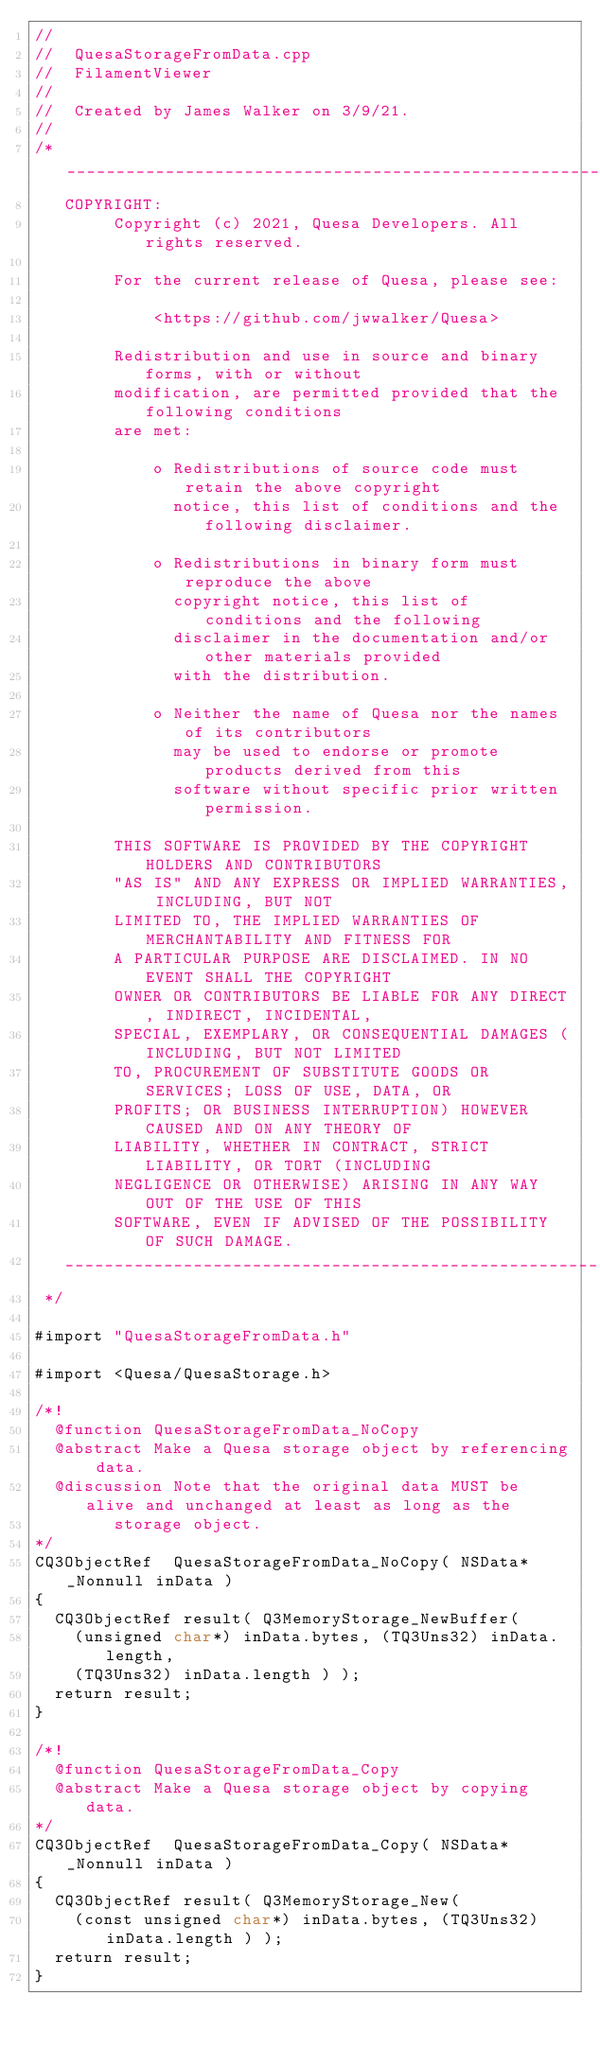Convert code to text. <code><loc_0><loc_0><loc_500><loc_500><_ObjectiveC_>//
//  QuesaStorageFromData.cpp
//  FilamentViewer
//
//  Created by James Walker on 3/9/21.
//
/* ___________________________________________________________________________
   COPYRIGHT:
        Copyright (c) 2021, Quesa Developers. All rights reserved.

        For the current release of Quesa, please see:

            <https://github.com/jwwalker/Quesa>
        
        Redistribution and use in source and binary forms, with or without
        modification, are permitted provided that the following conditions
        are met:
        
            o Redistributions of source code must retain the above copyright
              notice, this list of conditions and the following disclaimer.
        
            o Redistributions in binary form must reproduce the above
              copyright notice, this list of conditions and the following
              disclaimer in the documentation and/or other materials provided
              with the distribution.
        
            o Neither the name of Quesa nor the names of its contributors
              may be used to endorse or promote products derived from this
              software without specific prior written permission.
        
        THIS SOFTWARE IS PROVIDED BY THE COPYRIGHT HOLDERS AND CONTRIBUTORS
        "AS IS" AND ANY EXPRESS OR IMPLIED WARRANTIES, INCLUDING, BUT NOT
        LIMITED TO, THE IMPLIED WARRANTIES OF MERCHANTABILITY AND FITNESS FOR
        A PARTICULAR PURPOSE ARE DISCLAIMED. IN NO EVENT SHALL THE COPYRIGHT
        OWNER OR CONTRIBUTORS BE LIABLE FOR ANY DIRECT, INDIRECT, INCIDENTAL,
        SPECIAL, EXEMPLARY, OR CONSEQUENTIAL DAMAGES (INCLUDING, BUT NOT LIMITED
        TO, PROCUREMENT OF SUBSTITUTE GOODS OR SERVICES; LOSS OF USE, DATA, OR
        PROFITS; OR BUSINESS INTERRUPTION) HOWEVER CAUSED AND ON ANY THEORY OF
        LIABILITY, WHETHER IN CONTRACT, STRICT LIABILITY, OR TORT (INCLUDING
        NEGLIGENCE OR OTHERWISE) ARISING IN ANY WAY OUT OF THE USE OF THIS
        SOFTWARE, EVEN IF ADVISED OF THE POSSIBILITY OF SUCH DAMAGE.
   ___________________________________________________________________________
 */

#import "QuesaStorageFromData.h"

#import <Quesa/QuesaStorage.h>

/*!
	@function	QuesaStorageFromData_NoCopy
	@abstract	Make a Quesa storage object by referencing data.
	@discussion	Note that the original data MUST be alive and unchanged at least as long as the
				storage object.
*/
CQ3ObjectRef	QuesaStorageFromData_NoCopy( NSData* _Nonnull inData )
{
	CQ3ObjectRef result( Q3MemoryStorage_NewBuffer(
		(unsigned char*) inData.bytes, (TQ3Uns32) inData.length,
		(TQ3Uns32) inData.length ) );
	return result;
}

/*!
	@function	QuesaStorageFromData_Copy
	@abstract	Make a Quesa storage object by copying data.
*/
CQ3ObjectRef	QuesaStorageFromData_Copy( NSData* _Nonnull inData )
{
	CQ3ObjectRef result( Q3MemoryStorage_New(
		(const unsigned char*) inData.bytes, (TQ3Uns32) inData.length ) );
	return result;
}
</code> 